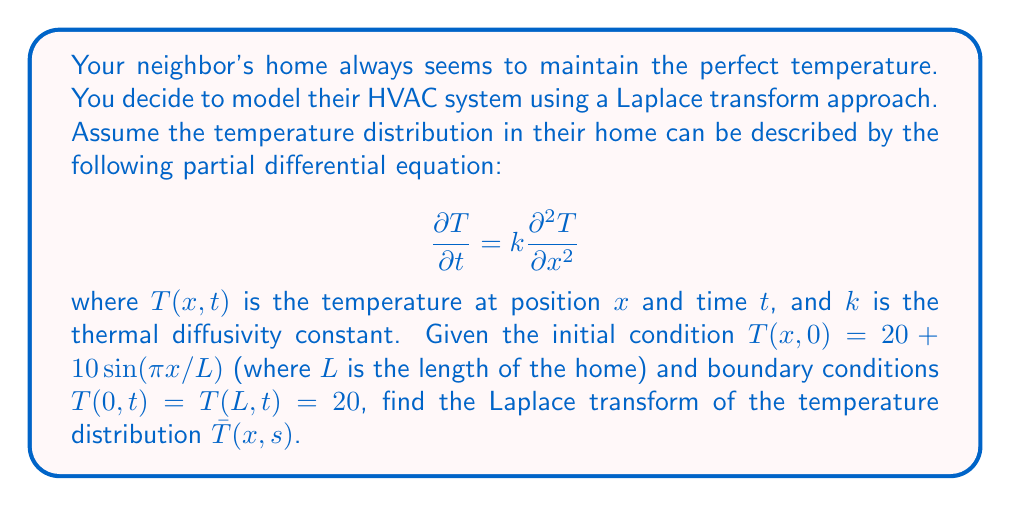Can you solve this math problem? Let's approach this step-by-step:

1) First, we take the Laplace transform of the heat equation with respect to $t$:

   $$\mathcal{L}\left\{\frac{\partial T}{\partial t}\right\} = k\mathcal{L}\left\{\frac{\partial^2 T}{\partial x^2}\right\}$$

2) Using the property of Laplace transforms for derivatives:

   $$s\bar{T}(x,s) - T(x,0) = k\frac{d^2\bar{T}}{dx^2}$$

3) Substituting the initial condition:

   $$s\bar{T}(x,s) - (20 + 10\sin(\pi x/L)) = k\frac{d^2\bar{T}}{dx^2}$$

4) Rearranging:

   $$k\frac{d^2\bar{T}}{dx^2} - s\bar{T}(x,s) = -20 - 10\sin(\pi x/L)$$

5) This is a non-homogeneous second-order ODE. The general solution will be of the form:

   $$\bar{T}(x,s) = \bar{T}_h(x,s) + \bar{T}_p(x,s)$$

   where $\bar{T}_h$ is the solution to the homogeneous equation and $\bar{T}_p$ is a particular solution.

6) For the homogeneous part:

   $$k\frac{d^2\bar{T}_h}{dx^2} - s\bar{T}_h = 0$$

   The characteristic equation is $kr^2 - s = 0$, giving $r = \pm\sqrt{s/k}$

   So, $\bar{T}_h(x,s) = A\exp(x\sqrt{s/k}) + B\exp(-x\sqrt{s/k})$

7) For the particular solution, we can guess a form:

   $$\bar{T}_p(x,s) = C + D\sin(\pi x/L)$$

8) Substituting this into the original ODE:

   $$k(-D(\pi/L)^2\sin(\pi x/L)) - s(C + D\sin(\pi x/L)) = -20 - 10\sin(\pi x/L)$$

9) Equating coefficients:

   $$-sC = -20 \implies C = 20/s$$
   $$-kD(\pi/L)^2 - sD = -10 \implies D = \frac{10}{s + k(\pi/L)^2}$$

10) Therefore, the general solution is:

    $$\bar{T}(x,s) = A\exp(x\sqrt{s/k}) + B\exp(-x\sqrt{s/k}) + \frac{20}{s} + \frac{10}{s + k(\pi/L)^2}\sin(\pi x/L)$$

11) Using the boundary conditions:

    At $x = 0$: $20 = A + B + 20/s$
    At $x = L$: $20 = A\exp(L\sqrt{s/k}) + B\exp(-L\sqrt{s/k}) + 20/s$

12) Solving these equations:

    $$A = B = 0$$

Therefore, the final solution is:

$$\bar{T}(x,s) = \frac{20}{s} + \frac{10}{s + k(\pi/L)^2}\sin(\pi x/L)$$
Answer: $$\bar{T}(x,s) = \frac{20}{s} + \frac{10}{s + k(\pi/L)^2}\sin(\pi x/L)$$ 